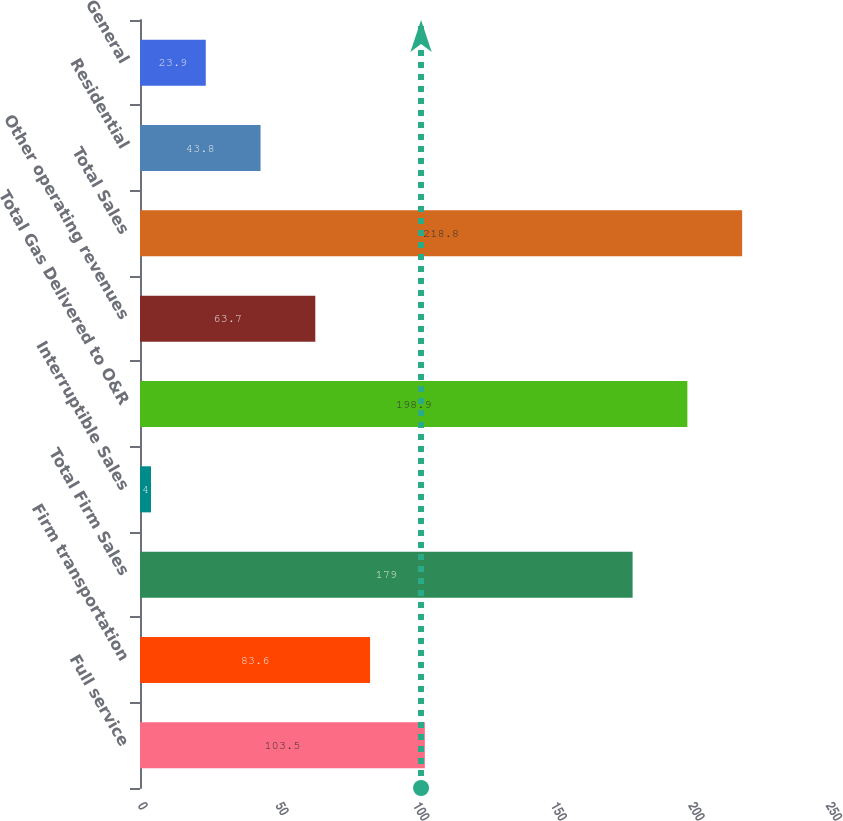Convert chart. <chart><loc_0><loc_0><loc_500><loc_500><bar_chart><fcel>Full service<fcel>Firm transportation<fcel>Total Firm Sales<fcel>Interruptible Sales<fcel>Total Gas Delivered to O&R<fcel>Other operating revenues<fcel>Total Sales<fcel>Residential<fcel>General<nl><fcel>103.5<fcel>83.6<fcel>179<fcel>4<fcel>198.9<fcel>63.7<fcel>218.8<fcel>43.8<fcel>23.9<nl></chart> 